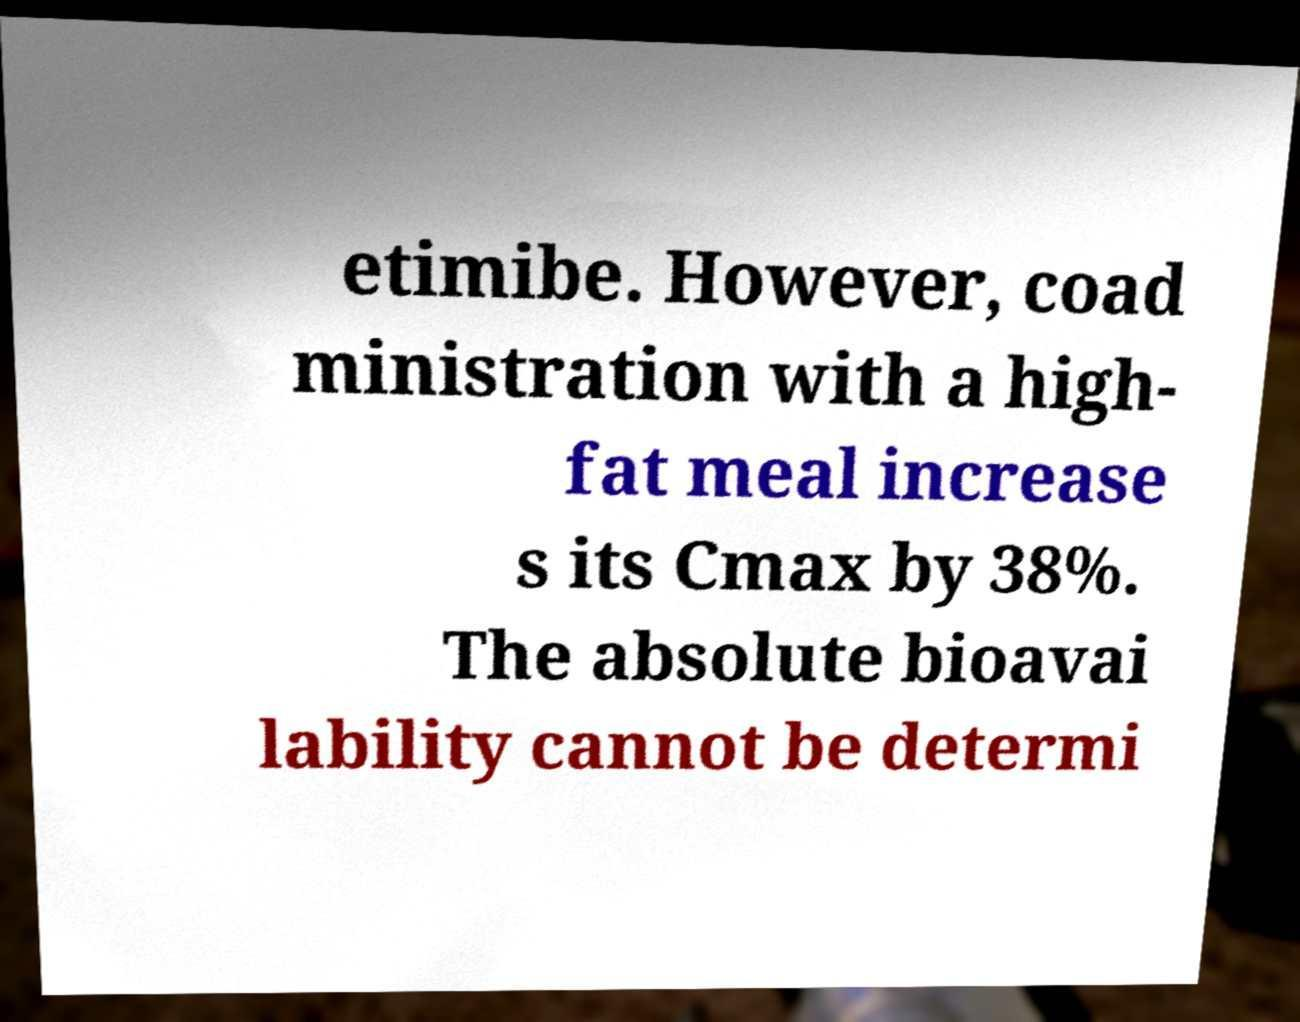Could you assist in decoding the text presented in this image and type it out clearly? etimibe. However, coad ministration with a high- fat meal increase s its Cmax by 38%. The absolute bioavai lability cannot be determi 